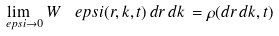<formula> <loc_0><loc_0><loc_500><loc_500>\lim _ { \ e p s i \to 0 } W ^ { \ } e p s i ( r , k , t ) \, d r \, d k \, = \rho ( d r \, d k , t )</formula> 